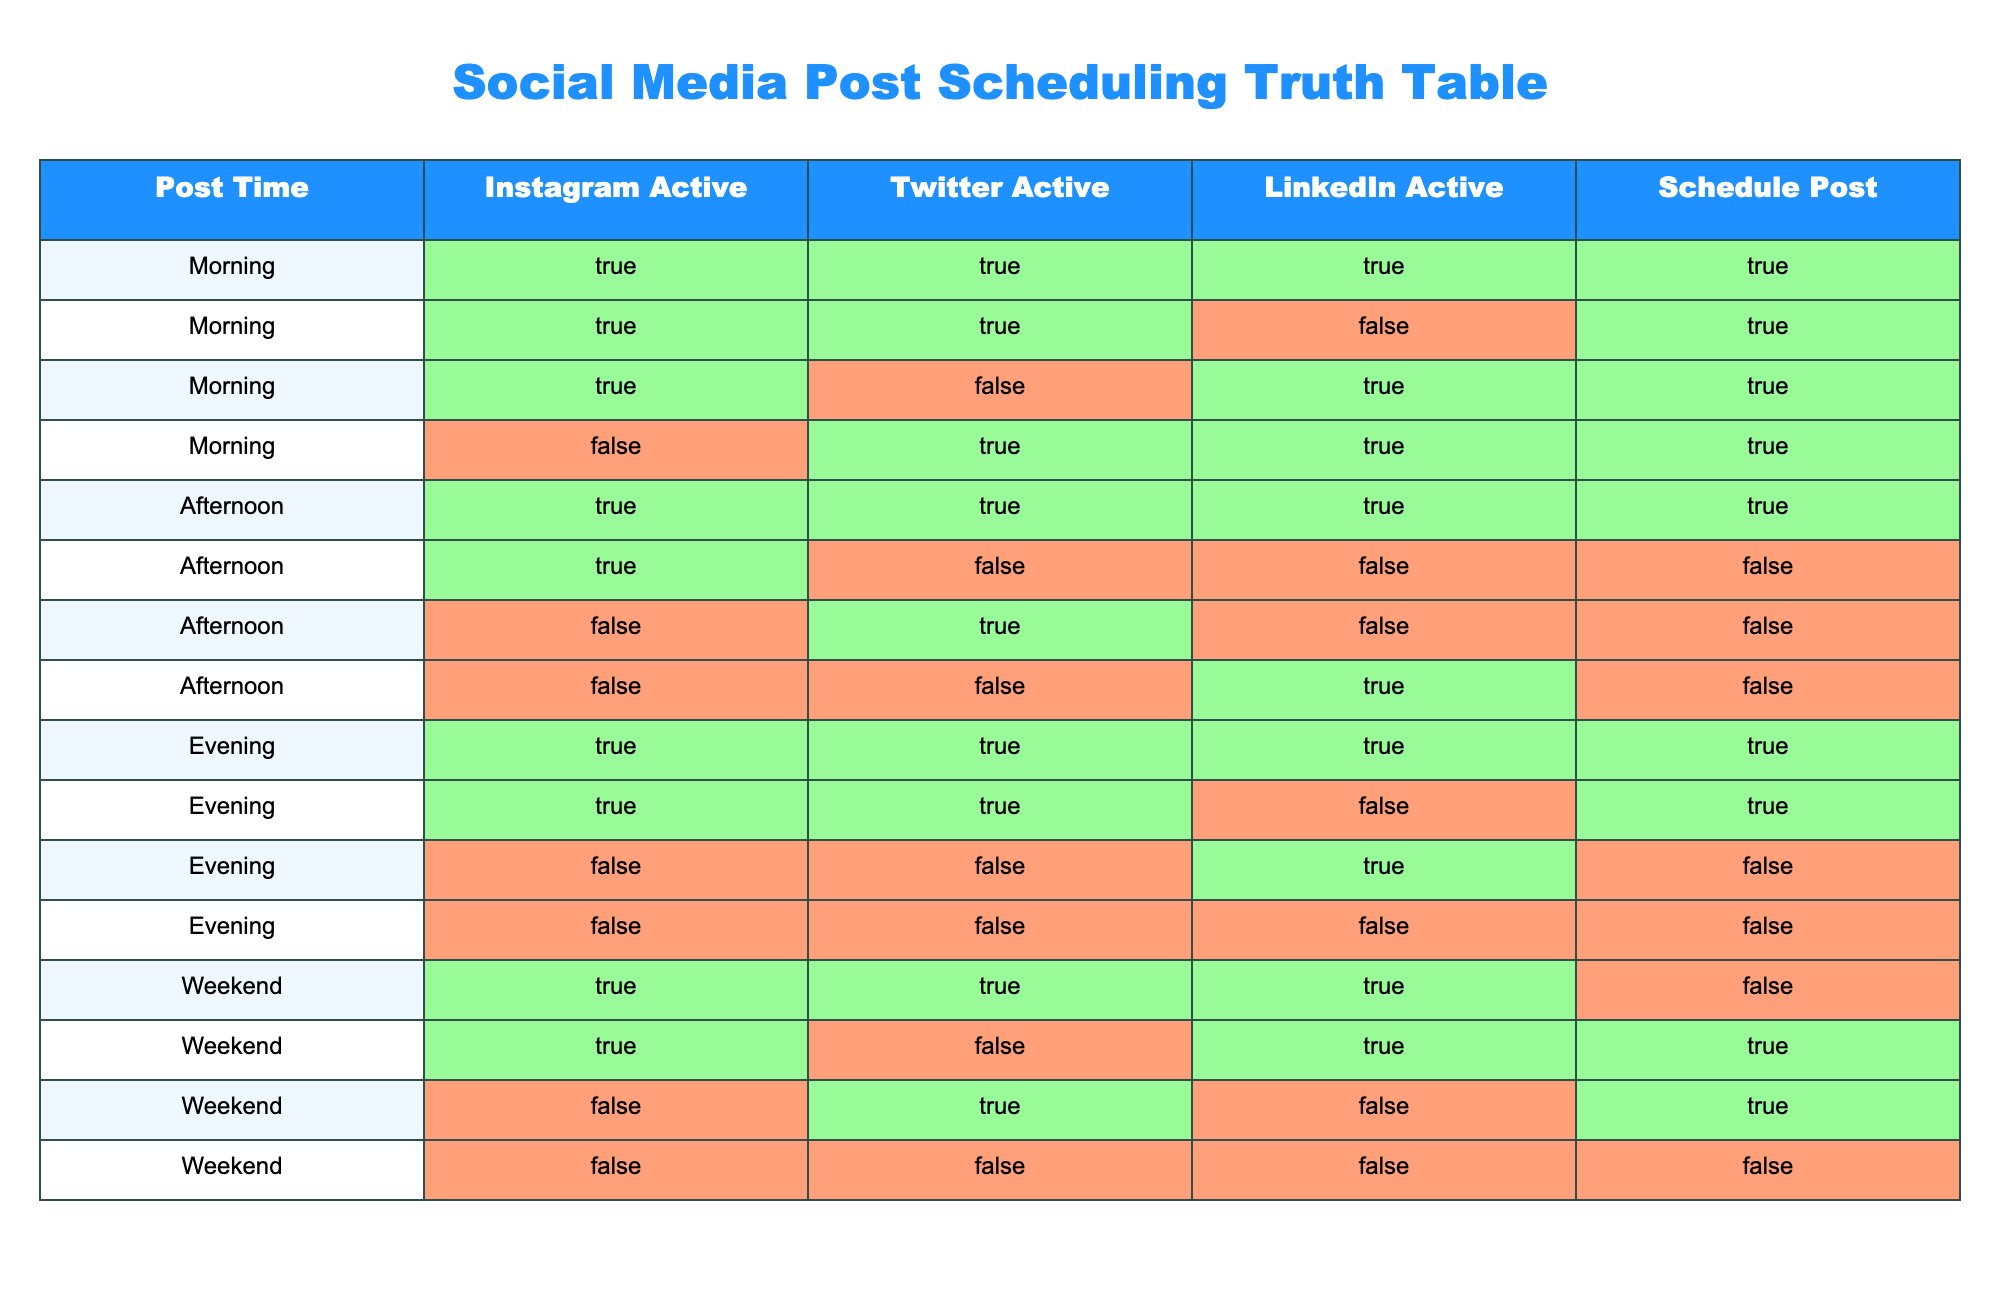What is the post schedule time when Instagram, Twitter, and LinkedIn are all active? By looking at the table, I can see that the only row where Instagram, Twitter, and LinkedIn are all marked as active (TRUE) is during the Morning and Afternoon post times. Therefore, the answer is both of these times.
Answer: Morning, Afternoon How many total times Instagram is active? To calculate the total number of times Instagram is active, I count the number of TRUE entries in the "Instagram Active" column. There are 9 TRUE entries.
Answer: 9 Does a post get scheduled if only Twitter is active in the Afternoon? Based on the table, when Twitter is active (TRUE) in the Afternoon, Instagram and LinkedIn are both FALSE. The "Schedule Post" column is marked as FALSE for that instance, confirming that the post does not get scheduled.
Answer: No In which time slot does a post get scheduled if Instagram and Twitter are both active but LinkedIn is not? Referring to the table, the only instance when Instagram and Twitter are both active (TRUE) but LinkedIn is not (FALSE) is during the Evening at one specific time. Looking at the "Schedule Post" column here shows that it is marked as TRUE. Therefore, a post gets scheduled during this time.
Answer: Evening How many total time slots have posts scheduled during the weekend? To find the total time slots for posts scheduled on the weekend, I will examine the "Schedule Post" column for the Weekend rows and see which ones show TRUE. In the table, there are 2 instances in the weekend row where posts are scheduled. Therefore, the answer is 2.
Answer: 2 Is there any time when all three platforms are inactive and the post is still scheduled? By checking the entries where all platforms are marked as inactive (FALSE), it can be seen that there are no entries in the "Schedule Post" column marked as TRUE simultaneously. Thus, a post is never scheduled when all platforms are inactive.
Answer: No What is the total number of posts scheduled during the morning? I can retrieve this by adding up all entries in the "Schedule Post" column that correspond to the Morning time slot. Looking through the Morning rows, I can count 5 instances where posts are scheduled, hence the total is 5.
Answer: 5 Which platforms are active when a post is scheduled on the evening? To determine this, I will filter the rows for the Evening time and check which platforms are marked as active where "Schedule Post" is TRUE. Analyzing the Evening slots, I find that both Instagram and Twitter are active at certain points.
Answer: Instagram, Twitter How many total posts are scheduled when LinkedIn is active during the afternoon? I check the Afternoon time slots to find out how many instances have LinkedIn marked as active (TRUE) in the "LinkedIn Active" column and also have "Schedule Post" as TRUE. There are none in that category, meaning no posts are scheduled when LinkedIn is active in the Afternoon.
Answer: 0 